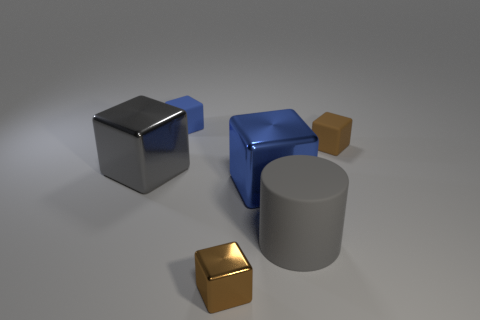What size is the metallic object that is the same color as the large matte cylinder?
Give a very brief answer. Large. Are the large gray cube to the left of the large matte object and the gray cylinder made of the same material?
Your answer should be very brief. No. How many things are either green balls or small blue rubber blocks?
Give a very brief answer. 1. What color is the metallic block that is the same size as the blue matte block?
Make the answer very short. Brown. How many objects are blue blocks in front of the big gray cube or small rubber objects behind the gray rubber cylinder?
Keep it short and to the point. 3. Is the number of tiny blue matte cubes that are behind the gray rubber object the same as the number of big gray cylinders?
Your answer should be very brief. Yes. Is the size of the gray object that is in front of the gray shiny object the same as the thing to the left of the tiny blue cube?
Provide a succinct answer. Yes. What number of other things are there of the same size as the brown matte block?
Keep it short and to the point. 2. There is a cube in front of the blue shiny cube that is in front of the large gray block; are there any rubber cubes that are left of it?
Make the answer very short. Yes. There is a metallic cube that is in front of the gray rubber cylinder; what is its size?
Keep it short and to the point. Small. 